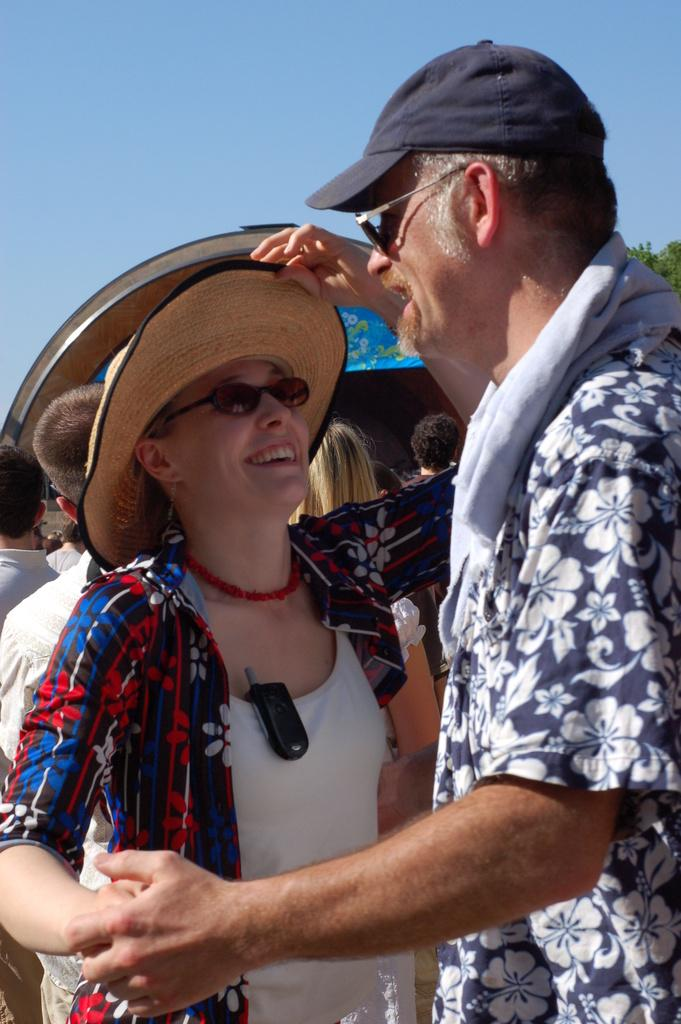What are the two people in the image doing? The two people in the image are dancing. How are the two people connected while dancing? The two people are holding hands. What can be seen in the background of the image? There is a group of people in the background of the image. What type of screw can be seen on the ground in the image? There is no screw present on the ground in the image. How does the land appear in the image? The term "land" refers to a geographical area, and it is not applicable to the image, as it does not depict a specific location or landscape. 